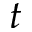<formula> <loc_0><loc_0><loc_500><loc_500>t</formula> 